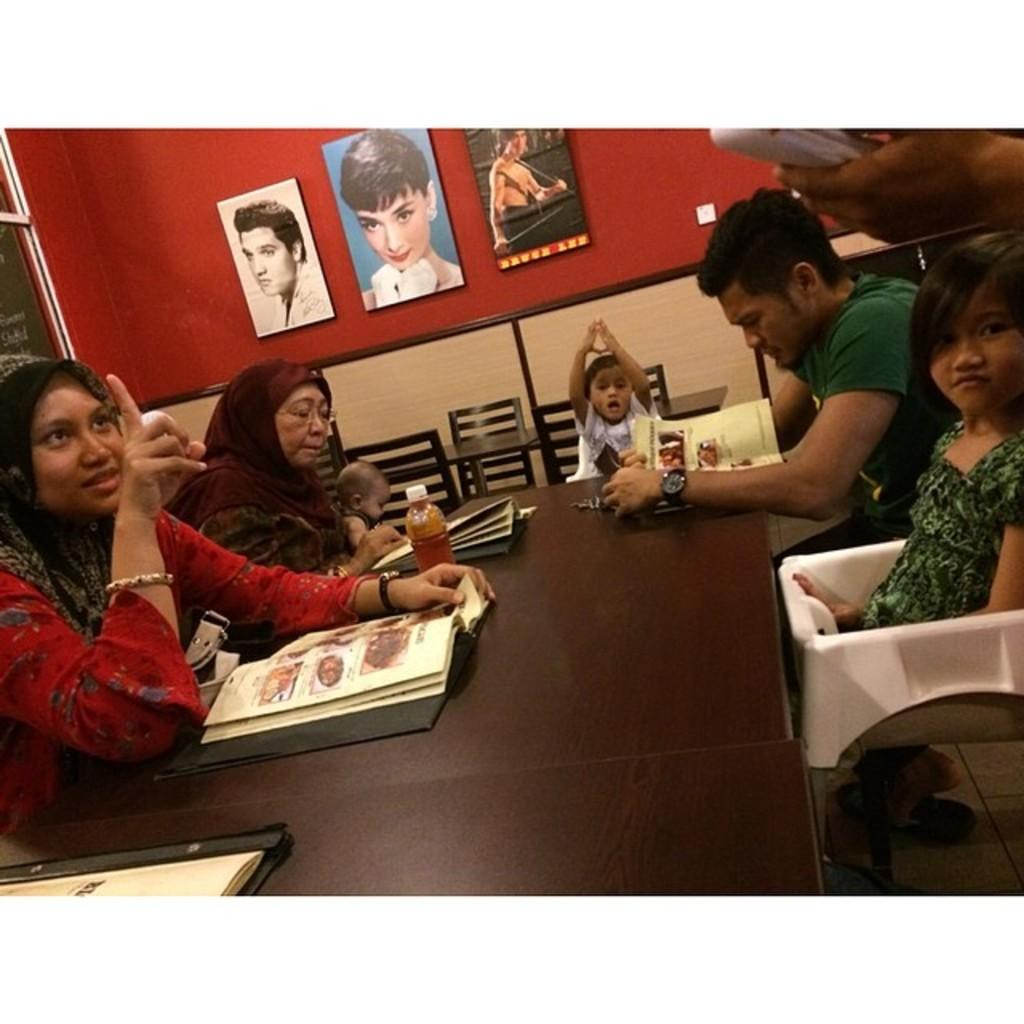Who is present in the image? There is a family in the image. What are the family members doing in the image? The family is ordering food. Can you describe any decorative elements in the image? There are photo frames fixed to a wall in the image. What type of verse can be seen written on the wall in the image? There is no verse written on the wall in the image; only photo frames are present. 